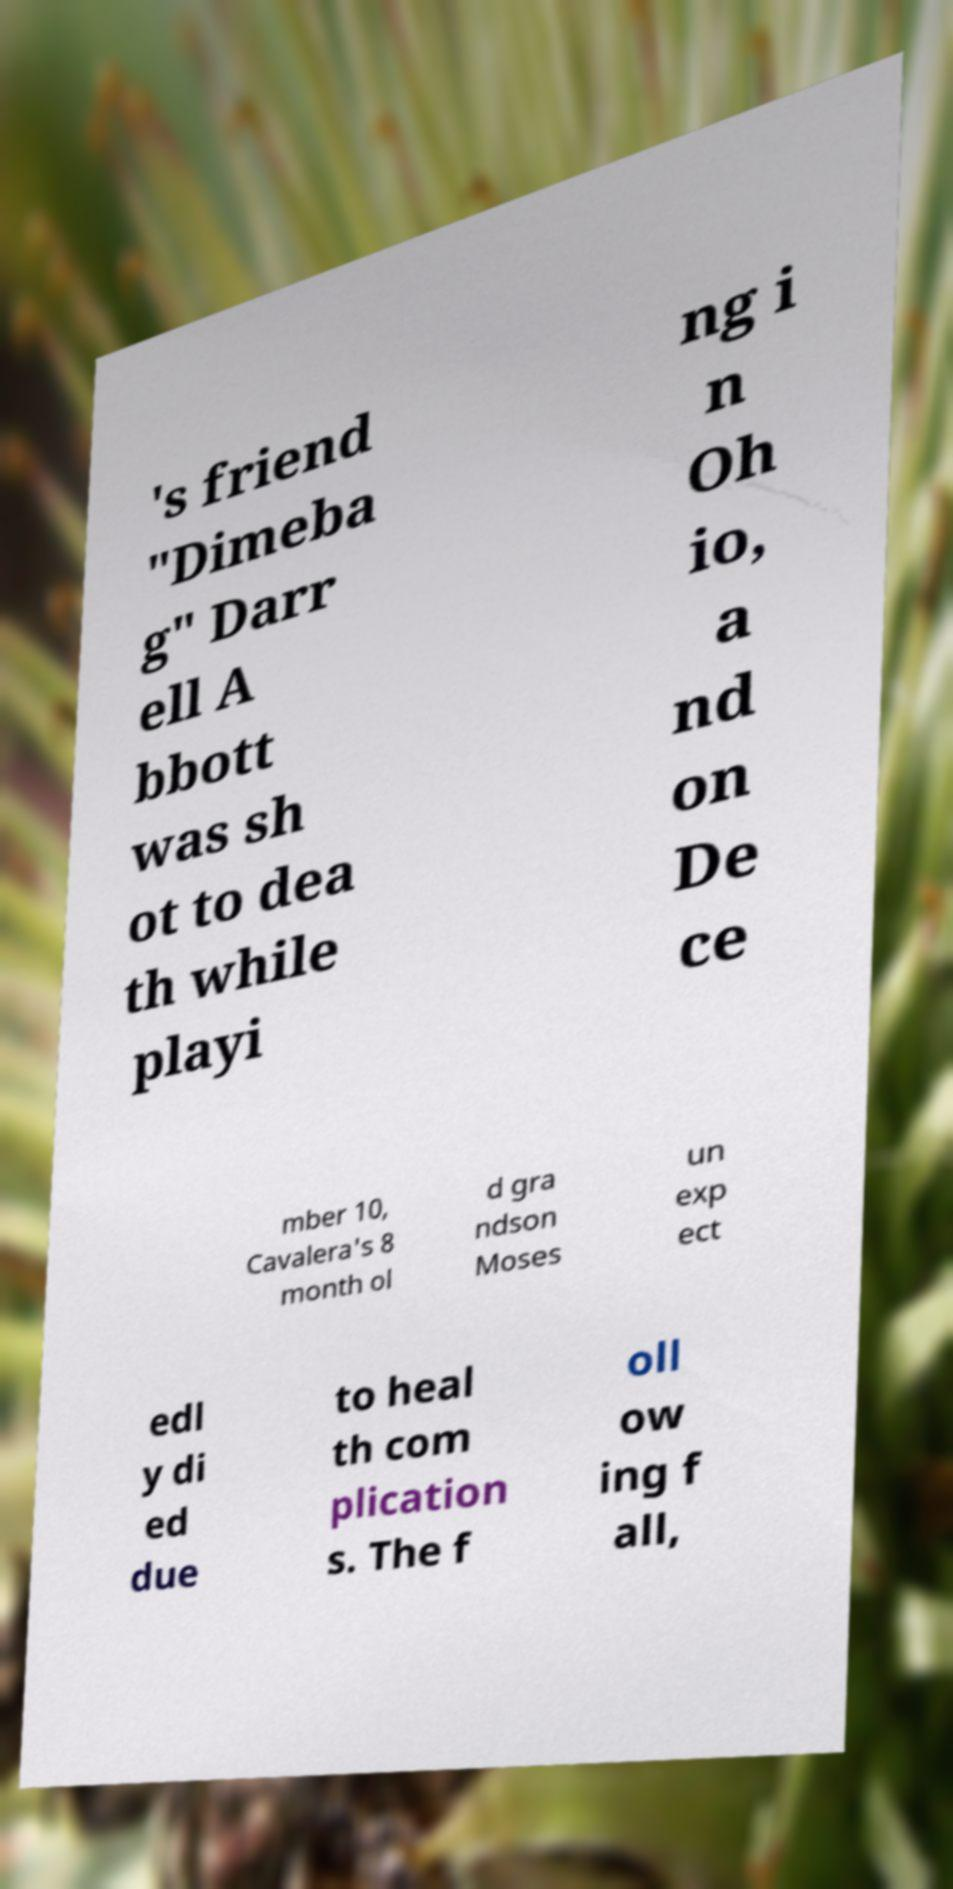I need the written content from this picture converted into text. Can you do that? 's friend "Dimeba g" Darr ell A bbott was sh ot to dea th while playi ng i n Oh io, a nd on De ce mber 10, Cavalera's 8 month ol d gra ndson Moses un exp ect edl y di ed due to heal th com plication s. The f oll ow ing f all, 